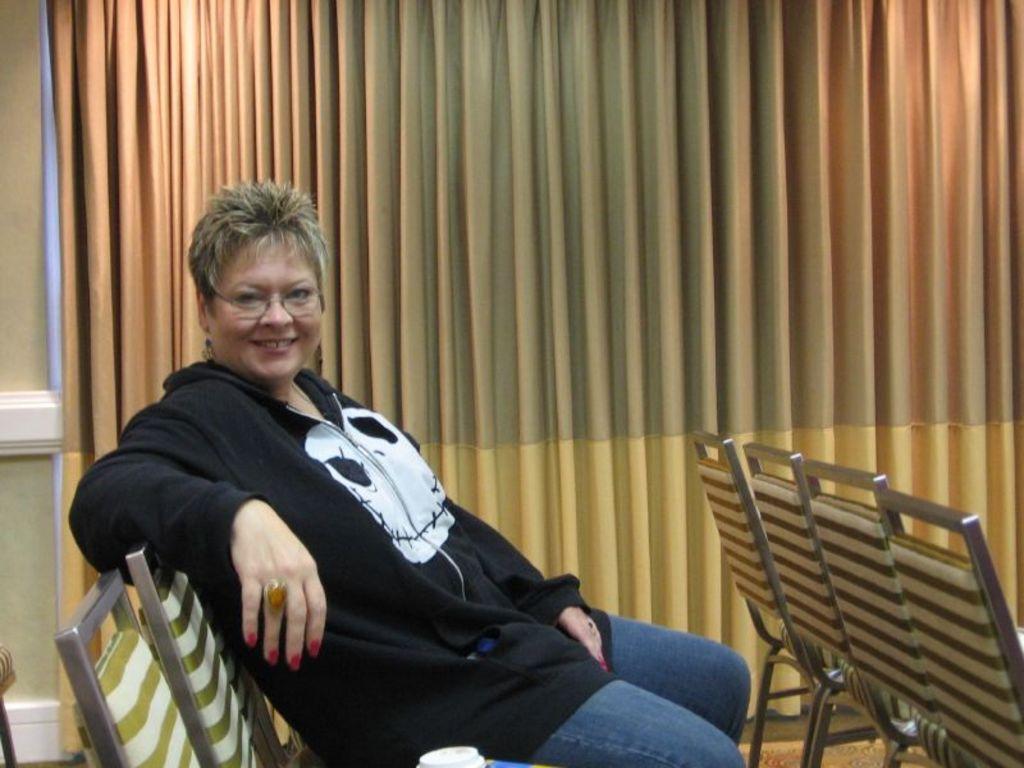Please provide a concise description of this image. This is a picture of a woman in black t shirt was sitting on a chair. Background of this woman there are curtains. 